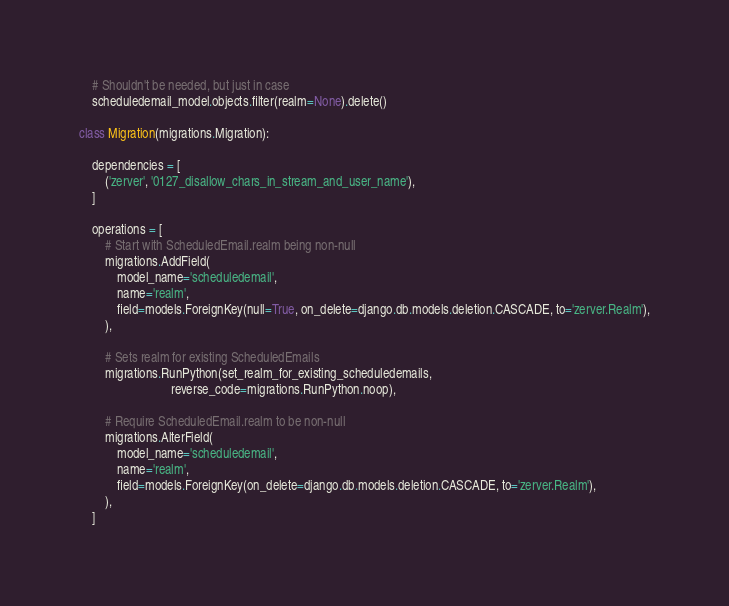Convert code to text. <code><loc_0><loc_0><loc_500><loc_500><_Python_>    # Shouldn't be needed, but just in case
    scheduledemail_model.objects.filter(realm=None).delete()

class Migration(migrations.Migration):

    dependencies = [
        ('zerver', '0127_disallow_chars_in_stream_and_user_name'),
    ]

    operations = [
        # Start with ScheduledEmail.realm being non-null
        migrations.AddField(
            model_name='scheduledemail',
            name='realm',
            field=models.ForeignKey(null=True, on_delete=django.db.models.deletion.CASCADE, to='zerver.Realm'),
        ),

        # Sets realm for existing ScheduledEmails
        migrations.RunPython(set_realm_for_existing_scheduledemails,
                             reverse_code=migrations.RunPython.noop),

        # Require ScheduledEmail.realm to be non-null
        migrations.AlterField(
            model_name='scheduledemail',
            name='realm',
            field=models.ForeignKey(on_delete=django.db.models.deletion.CASCADE, to='zerver.Realm'),
        ),
    ]
</code> 